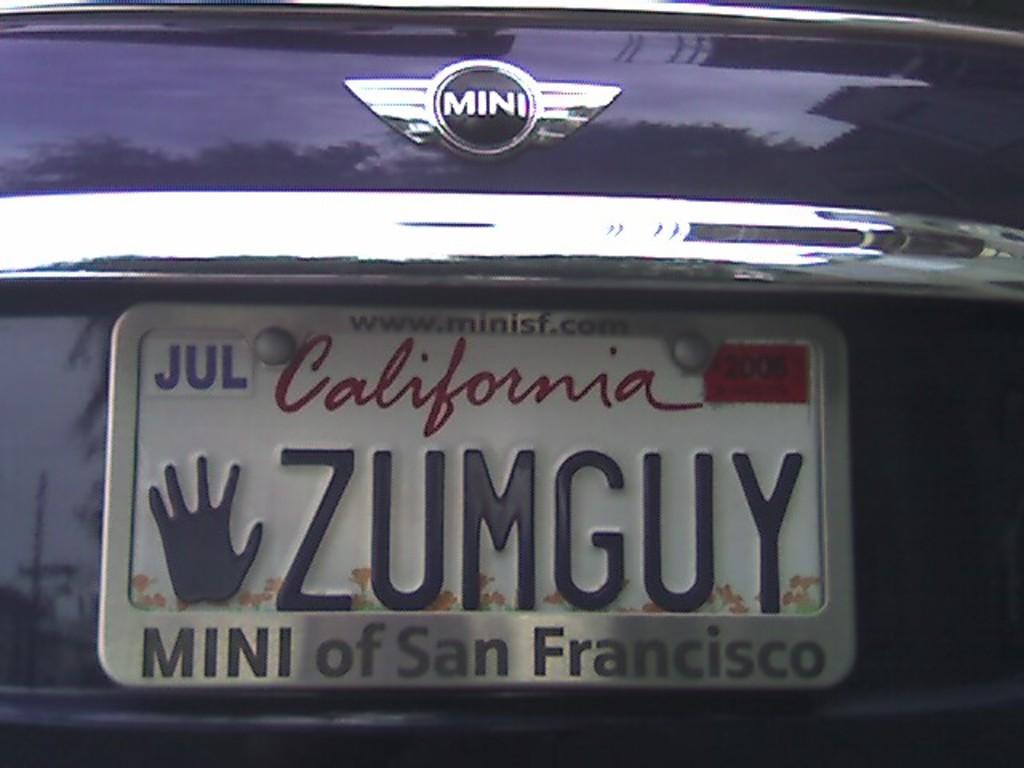<image>
Give a short and clear explanation of the subsequent image. The license plate is from the state of California. 